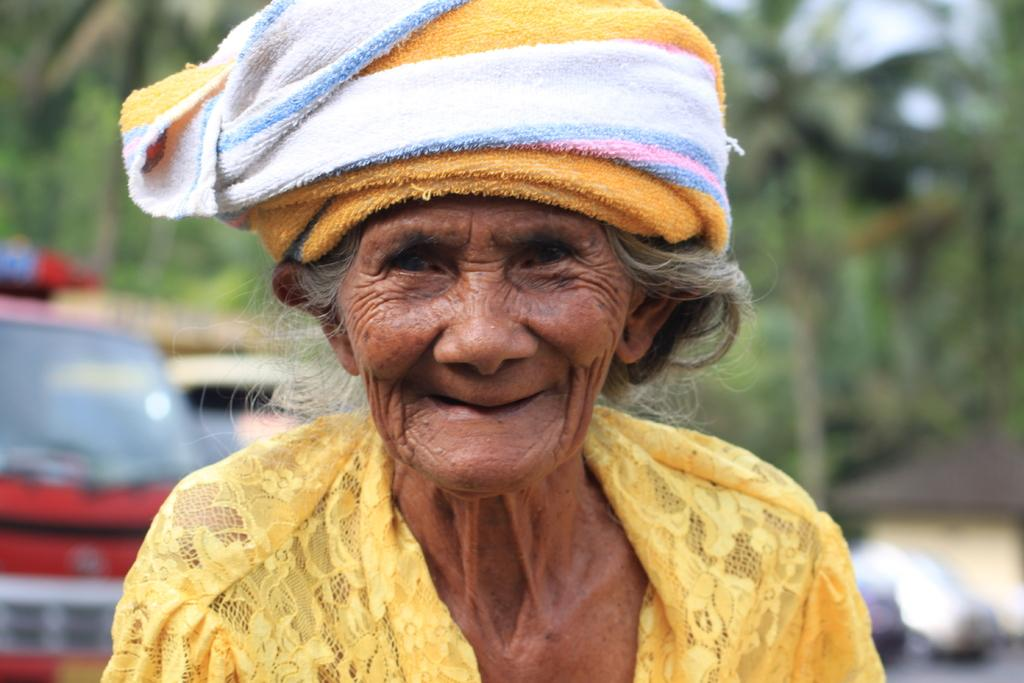Who is the main subject in the image? There is an old lady in the image. What is the old lady wearing? The old lady is wearing a yellow dress and a headband. What is the old lady's facial expression? The old lady is smiling. What can be seen on the left side of the image? There is a vehicle on the left side of the image. What is visible in the background of the image? There are trees in the background of the image. What process is taking place in the church in the image? There is no church or process visible in the image. 